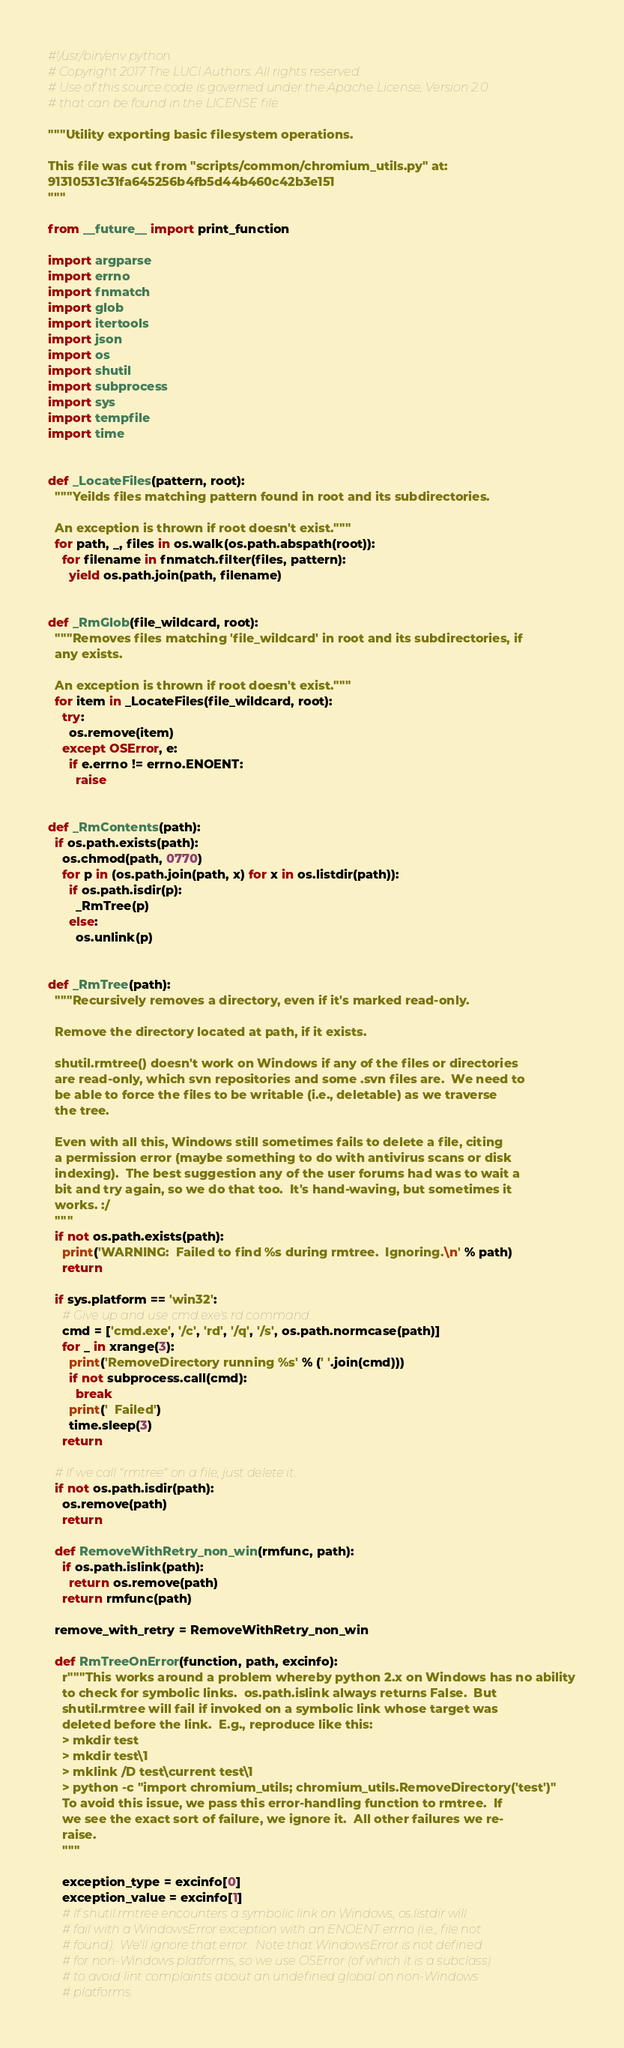Convert code to text. <code><loc_0><loc_0><loc_500><loc_500><_Python_>#!/usr/bin/env python
# Copyright 2017 The LUCI Authors. All rights reserved.
# Use of this source code is governed under the Apache License, Version 2.0
# that can be found in the LICENSE file.

"""Utility exporting basic filesystem operations.

This file was cut from "scripts/common/chromium_utils.py" at:
91310531c31fa645256b4fb5d44b460c42b3e151
"""

from __future__ import print_function

import argparse
import errno
import fnmatch
import glob
import itertools
import json
import os
import shutil
import subprocess
import sys
import tempfile
import time


def _LocateFiles(pattern, root):
  """Yeilds files matching pattern found in root and its subdirectories.

  An exception is thrown if root doesn't exist."""
  for path, _, files in os.walk(os.path.abspath(root)):
    for filename in fnmatch.filter(files, pattern):
      yield os.path.join(path, filename)


def _RmGlob(file_wildcard, root):
  """Removes files matching 'file_wildcard' in root and its subdirectories, if
  any exists.

  An exception is thrown if root doesn't exist."""
  for item in _LocateFiles(file_wildcard, root):
    try:
      os.remove(item)
    except OSError, e:
      if e.errno != errno.ENOENT:
        raise


def _RmContents(path):
  if os.path.exists(path):
    os.chmod(path, 0770)
    for p in (os.path.join(path, x) for x in os.listdir(path)):
      if os.path.isdir(p):
        _RmTree(p)
      else:
        os.unlink(p)


def _RmTree(path):
  """Recursively removes a directory, even if it's marked read-only.

  Remove the directory located at path, if it exists.

  shutil.rmtree() doesn't work on Windows if any of the files or directories
  are read-only, which svn repositories and some .svn files are.  We need to
  be able to force the files to be writable (i.e., deletable) as we traverse
  the tree.

  Even with all this, Windows still sometimes fails to delete a file, citing
  a permission error (maybe something to do with antivirus scans or disk
  indexing).  The best suggestion any of the user forums had was to wait a
  bit and try again, so we do that too.  It's hand-waving, but sometimes it
  works. :/
  """
  if not os.path.exists(path):
    print('WARNING:  Failed to find %s during rmtree.  Ignoring.\n' % path)
    return

  if sys.platform == 'win32':
    # Give up and use cmd.exe's rd command.
    cmd = ['cmd.exe', '/c', 'rd', '/q', '/s', os.path.normcase(path)]
    for _ in xrange(3):
      print('RemoveDirectory running %s' % (' '.join(cmd)))
      if not subprocess.call(cmd):
        break
      print('  Failed')
      time.sleep(3)
    return

  # If we call "rmtree" on a file, just delete it.
  if not os.path.isdir(path):
    os.remove(path)
    return

  def RemoveWithRetry_non_win(rmfunc, path):
    if os.path.islink(path):
      return os.remove(path)
    return rmfunc(path)

  remove_with_retry = RemoveWithRetry_non_win

  def RmTreeOnError(function, path, excinfo):
    r"""This works around a problem whereby python 2.x on Windows has no ability
    to check for symbolic links.  os.path.islink always returns False.  But
    shutil.rmtree will fail if invoked on a symbolic link whose target was
    deleted before the link.  E.g., reproduce like this:
    > mkdir test
    > mkdir test\1
    > mklink /D test\current test\1
    > python -c "import chromium_utils; chromium_utils.RemoveDirectory('test')"
    To avoid this issue, we pass this error-handling function to rmtree.  If
    we see the exact sort of failure, we ignore it.  All other failures we re-
    raise.
    """

    exception_type = excinfo[0]
    exception_value = excinfo[1]
    # If shutil.rmtree encounters a symbolic link on Windows, os.listdir will
    # fail with a WindowsError exception with an ENOENT errno (i.e., file not
    # found).  We'll ignore that error.  Note that WindowsError is not defined
    # for non-Windows platforms, so we use OSError (of which it is a subclass)
    # to avoid lint complaints about an undefined global on non-Windows
    # platforms.</code> 